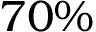Convert formula to latex. <formula><loc_0><loc_0><loc_500><loc_500>7 0 \%</formula> 